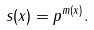Convert formula to latex. <formula><loc_0><loc_0><loc_500><loc_500>s ( x ) = p ^ { m ( x ) } .</formula> 